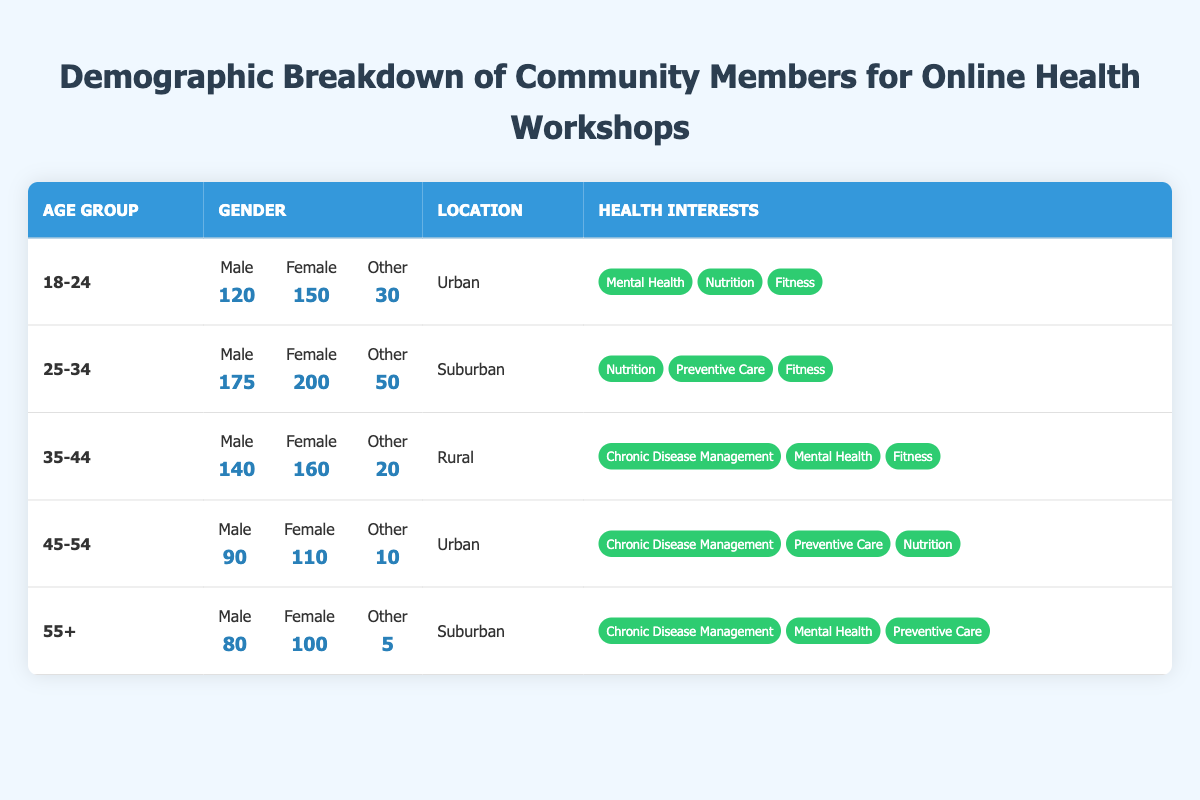What is the total number of male participants in the 18-24 age group? The male count for the 18-24 age group is stated in the table as 120.
Answer: 120 What are the health interests of the participants in the 25-34 age group? The health interests listed for this age group are Nutrition, Preventive Care, and Fitness.
Answer: Nutrition, Preventive Care, Fitness How many female participants are there in the 35-44 age group? The table indicates that there are 160 female participants in the 35-44 age group.
Answer: 160 Which age group has the highest total number of participants? The 25-34 age group has 175 males, 200 females, and 50 others, totaling 425 participants, which is more than any other age group.
Answer: 25-34 Is the majority of participants in the 45-54 age group female? There are 110 females and 90 males in this age group; female count is higher than male count, making them the majority.
Answer: Yes What is the average number of 'Other' gender participants across all age groups? Adding the 'Other' participants: 30 + 50 + 20 + 10 + 5 = 115, and dividing by 5 age groups gives an average of 115/5 = 23.
Answer: 23 How many participants from the Urban area belong to the 35-44 age group? The table shows that the 35-44 age group participants are from the Rural area; thus, there are no participants from the Urban area in this age group.
Answer: 0 What is the total number of participants in the 55+ age group? The total for the 55+ age group is 80 males, 100 females, and 5 others, which sums up to 185 participants.
Answer: 185 In which age group do we see the least number of participants in the 'Other' category? The 55+ age group has the least, with only 5 participants in the 'Other' category, compared to others.
Answer: 55+ Which demographic has the highest interest in Mental Health? The 18-24 and 55+ age groups both show a strong focus on Mental Health, but the count cannot be directly compared without specific interest numbers.
Answer: 18-24 and 55+ (equal interest) 